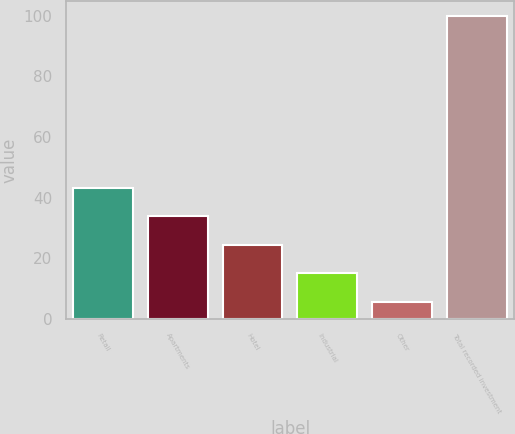Convert chart. <chart><loc_0><loc_0><loc_500><loc_500><bar_chart><fcel>Retail<fcel>Apartments<fcel>Hotel<fcel>Industrial<fcel>Other<fcel>Total recorded investment<nl><fcel>43.36<fcel>33.92<fcel>24.48<fcel>15.04<fcel>5.6<fcel>100<nl></chart> 